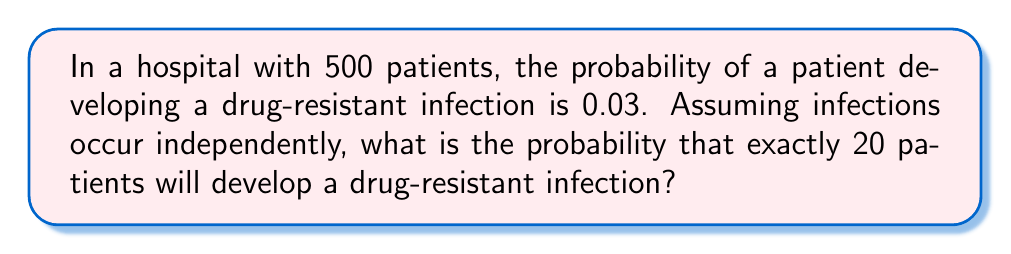Could you help me with this problem? This problem can be solved using the binomial probability distribution. The binomial distribution is appropriate when we have a fixed number of independent trials (patients in this case), each with the same probability of success (developing a drug-resistant infection).

Let's define our variables:
$n = 500$ (number of patients)
$p = 0.03$ (probability of developing a drug-resistant infection)
$k = 20$ (number of patients we want to develop the infection)

The probability mass function for the binomial distribution is:

$$ P(X = k) = \binom{n}{k} p^k (1-p)^{n-k} $$

Where $\binom{n}{k}$ is the binomial coefficient, calculated as:

$$ \binom{n}{k} = \frac{n!}{k!(n-k)!} $$

Let's calculate step by step:

1) First, we calculate the binomial coefficient:

   $\binom{500}{20} = \frac{500!}{20!(500-20)!} = \frac{500!}{20!480!} = 2.70 \times 10^{32}$

2) Now, we calculate $p^k$:

   $0.03^{20} = 3.49 \times 10^{-34}$

3) Next, we calculate $(1-p)^{n-k}$:

   $0.97^{480} = 1.08 \times 10^{-7}$

4) Finally, we multiply all these terms:

   $P(X = 20) = 2.70 \times 10^{32} \times 3.49 \times 10^{-34} \times 1.08 \times 10^{-7} = 0.0101$

Therefore, the probability of exactly 20 patients developing a drug-resistant infection is approximately 0.0101 or 1.01%.
Answer: 0.0101 or 1.01% 